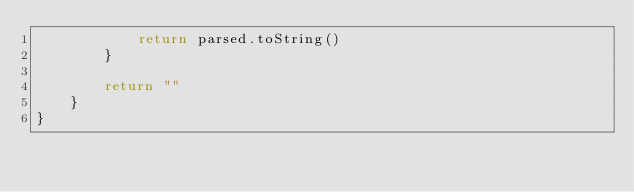<code> <loc_0><loc_0><loc_500><loc_500><_Kotlin_>            return parsed.toString()
        }

        return ""
    }
}</code> 